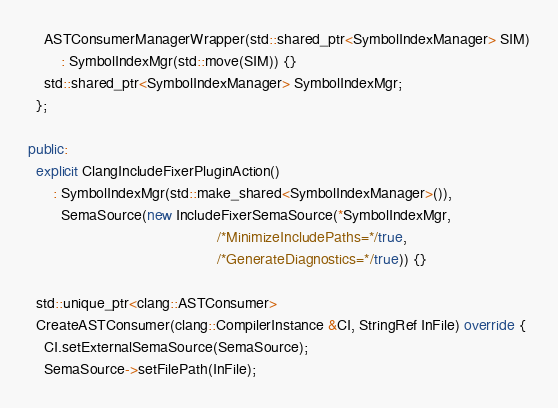Convert code to text. <code><loc_0><loc_0><loc_500><loc_500><_C++_>    ASTConsumerManagerWrapper(std::shared_ptr<SymbolIndexManager> SIM)
        : SymbolIndexMgr(std::move(SIM)) {}
    std::shared_ptr<SymbolIndexManager> SymbolIndexMgr;
  };

public:
  explicit ClangIncludeFixerPluginAction()
      : SymbolIndexMgr(std::make_shared<SymbolIndexManager>()),
        SemaSource(new IncludeFixerSemaSource(*SymbolIndexMgr,
                                              /*MinimizeIncludePaths=*/true,
                                              /*GenerateDiagnostics=*/true)) {}

  std::unique_ptr<clang::ASTConsumer>
  CreateASTConsumer(clang::CompilerInstance &CI, StringRef InFile) override {
    CI.setExternalSemaSource(SemaSource);
    SemaSource->setFilePath(InFile);</code> 